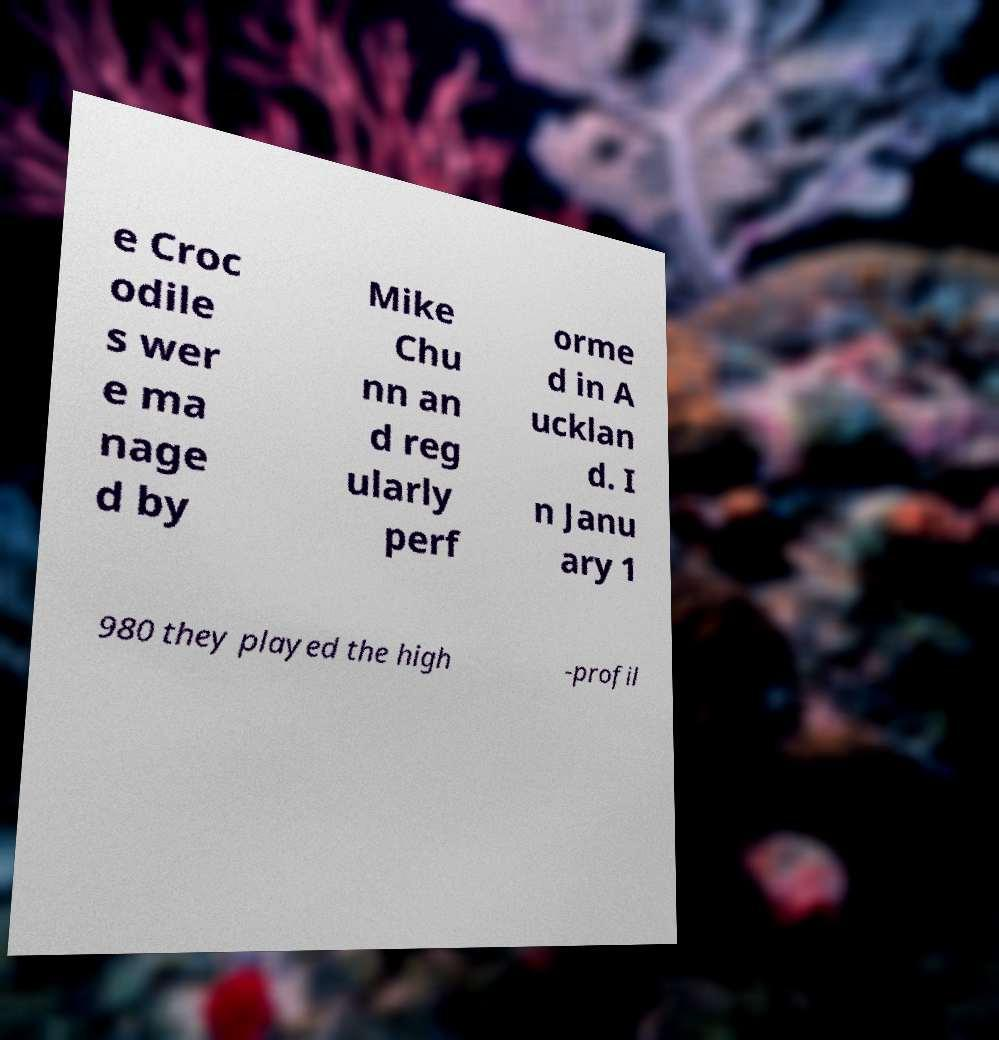Can you accurately transcribe the text from the provided image for me? e Croc odile s wer e ma nage d by Mike Chu nn an d reg ularly perf orme d in A ucklan d. I n Janu ary 1 980 they played the high -profil 